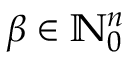Convert formula to latex. <formula><loc_0><loc_0><loc_500><loc_500>\beta \in { \mathbb { N } } _ { 0 } ^ { n }</formula> 